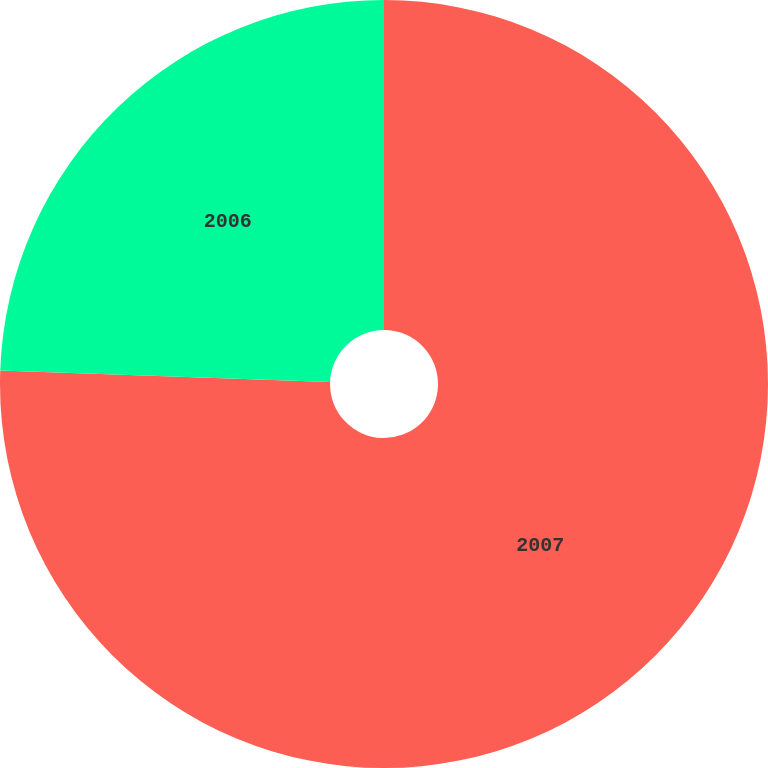Convert chart to OTSL. <chart><loc_0><loc_0><loc_500><loc_500><pie_chart><fcel>2007<fcel>2006<nl><fcel>75.56%<fcel>24.44%<nl></chart> 